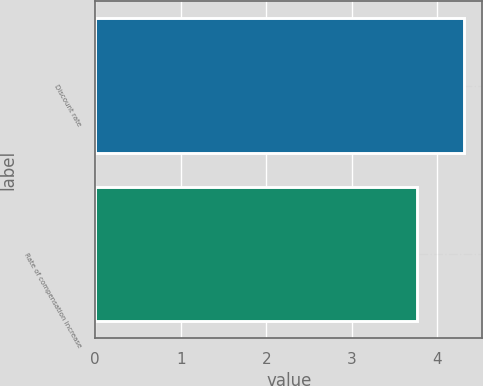<chart> <loc_0><loc_0><loc_500><loc_500><bar_chart><fcel>Discount rate<fcel>Rate of compensation increase<nl><fcel>4.31<fcel>3.76<nl></chart> 